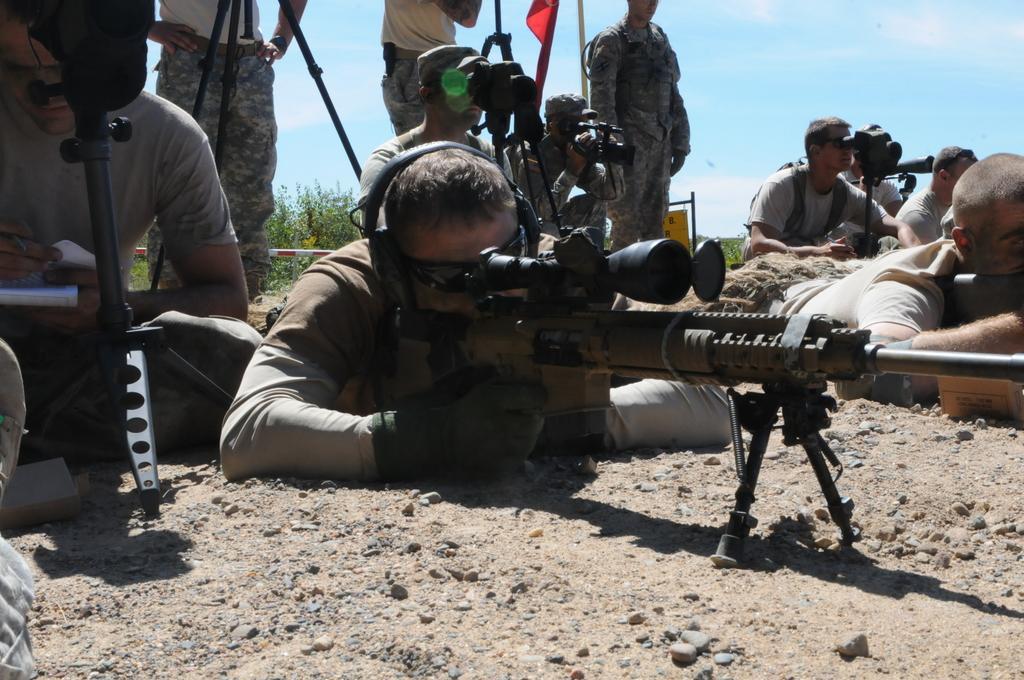In one or two sentences, can you explain what this image depicts? In the center of the image we can see two persons are lying on the ground and holding the guns. On the left side of the image we can see a man is sitting and holding a book and writing, in-front of him we can see a stand. In the background of the image we can see some persons are sitting and some of them are standing and some of them are holding the cameras. And also we can see stand, flag, pole, plants. At the top of the image we can see the clouds are present in the sky. At the bottom of the image we can see the ground. 